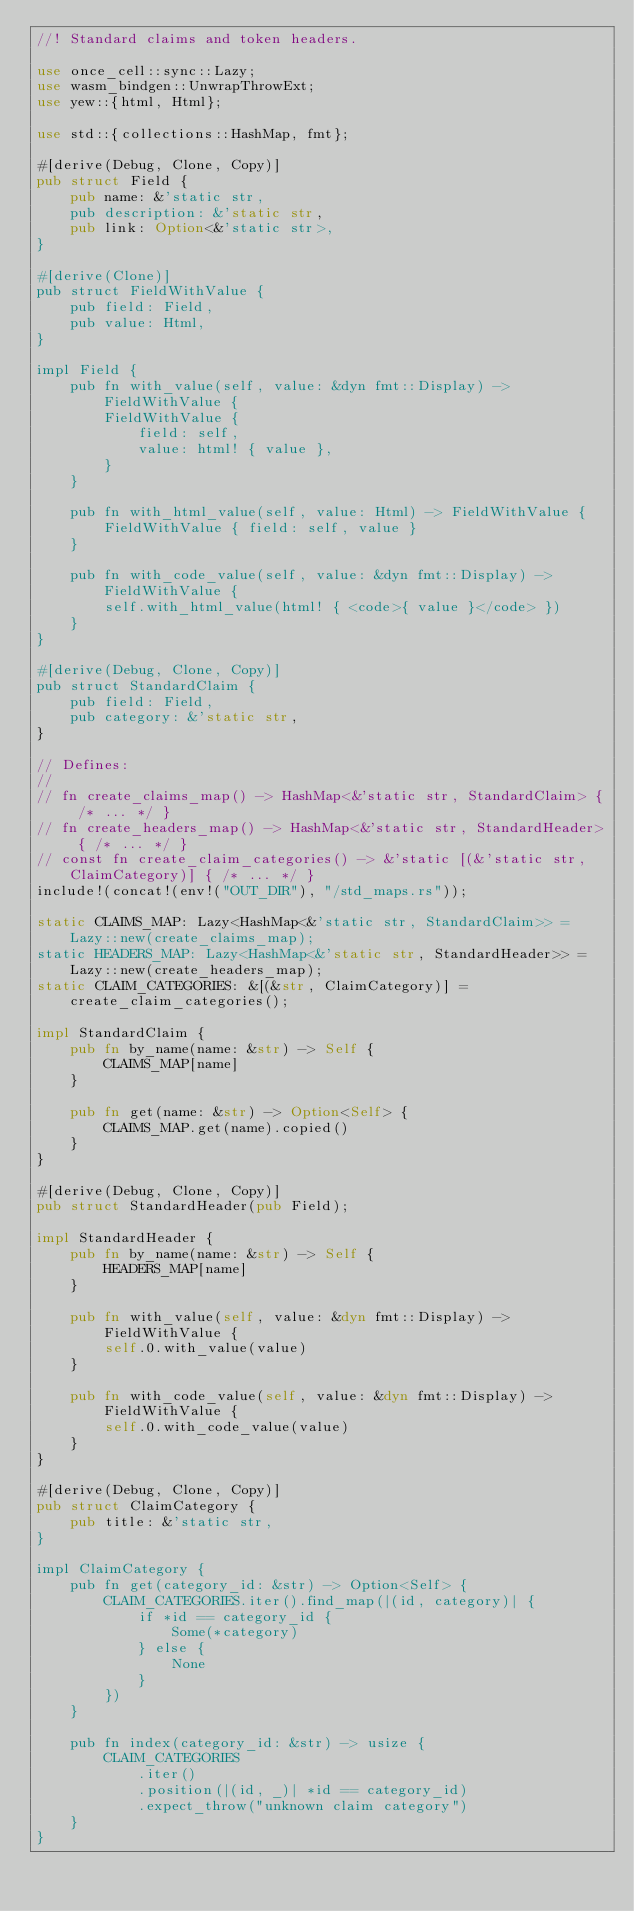<code> <loc_0><loc_0><loc_500><loc_500><_Rust_>//! Standard claims and token headers.

use once_cell::sync::Lazy;
use wasm_bindgen::UnwrapThrowExt;
use yew::{html, Html};

use std::{collections::HashMap, fmt};

#[derive(Debug, Clone, Copy)]
pub struct Field {
    pub name: &'static str,
    pub description: &'static str,
    pub link: Option<&'static str>,
}

#[derive(Clone)]
pub struct FieldWithValue {
    pub field: Field,
    pub value: Html,
}

impl Field {
    pub fn with_value(self, value: &dyn fmt::Display) -> FieldWithValue {
        FieldWithValue {
            field: self,
            value: html! { value },
        }
    }

    pub fn with_html_value(self, value: Html) -> FieldWithValue {
        FieldWithValue { field: self, value }
    }

    pub fn with_code_value(self, value: &dyn fmt::Display) -> FieldWithValue {
        self.with_html_value(html! { <code>{ value }</code> })
    }
}

#[derive(Debug, Clone, Copy)]
pub struct StandardClaim {
    pub field: Field,
    pub category: &'static str,
}

// Defines:
//
// fn create_claims_map() -> HashMap<&'static str, StandardClaim> { /* ... */ }
// fn create_headers_map() -> HashMap<&'static str, StandardHeader> { /* ... */ }
// const fn create_claim_categories() -> &'static [(&'static str, ClaimCategory)] { /* ... */ }
include!(concat!(env!("OUT_DIR"), "/std_maps.rs"));

static CLAIMS_MAP: Lazy<HashMap<&'static str, StandardClaim>> = Lazy::new(create_claims_map);
static HEADERS_MAP: Lazy<HashMap<&'static str, StandardHeader>> = Lazy::new(create_headers_map);
static CLAIM_CATEGORIES: &[(&str, ClaimCategory)] = create_claim_categories();

impl StandardClaim {
    pub fn by_name(name: &str) -> Self {
        CLAIMS_MAP[name]
    }

    pub fn get(name: &str) -> Option<Self> {
        CLAIMS_MAP.get(name).copied()
    }
}

#[derive(Debug, Clone, Copy)]
pub struct StandardHeader(pub Field);

impl StandardHeader {
    pub fn by_name(name: &str) -> Self {
        HEADERS_MAP[name]
    }

    pub fn with_value(self, value: &dyn fmt::Display) -> FieldWithValue {
        self.0.with_value(value)
    }

    pub fn with_code_value(self, value: &dyn fmt::Display) -> FieldWithValue {
        self.0.with_code_value(value)
    }
}

#[derive(Debug, Clone, Copy)]
pub struct ClaimCategory {
    pub title: &'static str,
}

impl ClaimCategory {
    pub fn get(category_id: &str) -> Option<Self> {
        CLAIM_CATEGORIES.iter().find_map(|(id, category)| {
            if *id == category_id {
                Some(*category)
            } else {
                None
            }
        })
    }

    pub fn index(category_id: &str) -> usize {
        CLAIM_CATEGORIES
            .iter()
            .position(|(id, _)| *id == category_id)
            .expect_throw("unknown claim category")
    }
}
</code> 